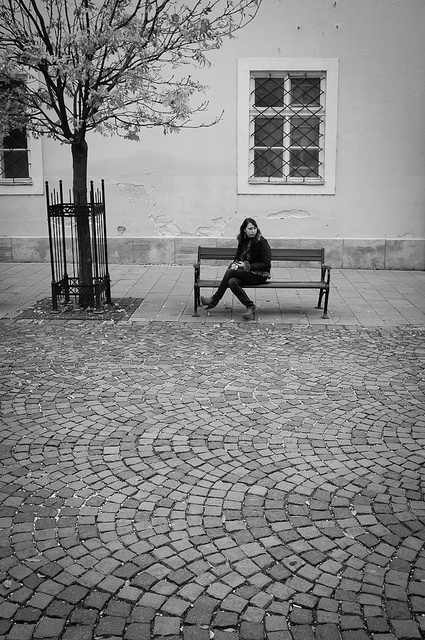Describe the objects in this image and their specific colors. I can see bench in gray, darkgray, black, and lightgray tones and people in gray, black, darkgray, and lightgray tones in this image. 